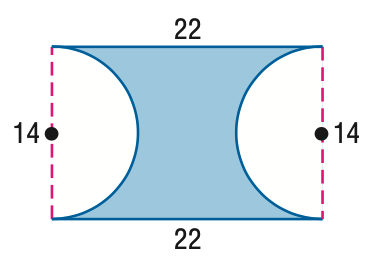Question: Find the area of the figure. Round to the nearest tenth if necessary.
Choices:
A. 154.1
B. 231.0
C. 307.6
D. 308
Answer with the letter. Answer: A 